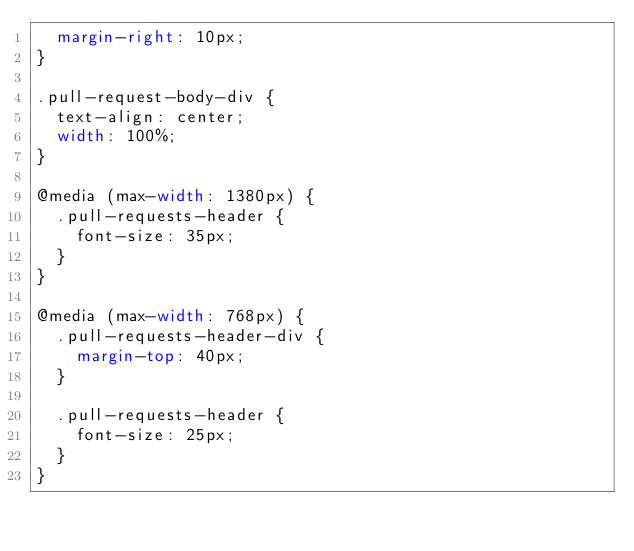<code> <loc_0><loc_0><loc_500><loc_500><_CSS_>  margin-right: 10px;
}

.pull-request-body-div {
  text-align: center;
  width: 100%;
}

@media (max-width: 1380px) {
  .pull-requests-header {
    font-size: 35px;
  }
}

@media (max-width: 768px) {
  .pull-requests-header-div {
    margin-top: 40px;
  }

  .pull-requests-header {
    font-size: 25px;
  }
}
</code> 